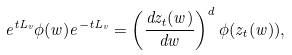Convert formula to latex. <formula><loc_0><loc_0><loc_500><loc_500>e ^ { t L _ { v } } \phi ( w ) e ^ { - t L _ { v } } = \left ( \frac { d z _ { t } ( w ) } { d w } \right ) ^ { d } \phi ( z _ { t } ( w ) ) ,</formula> 